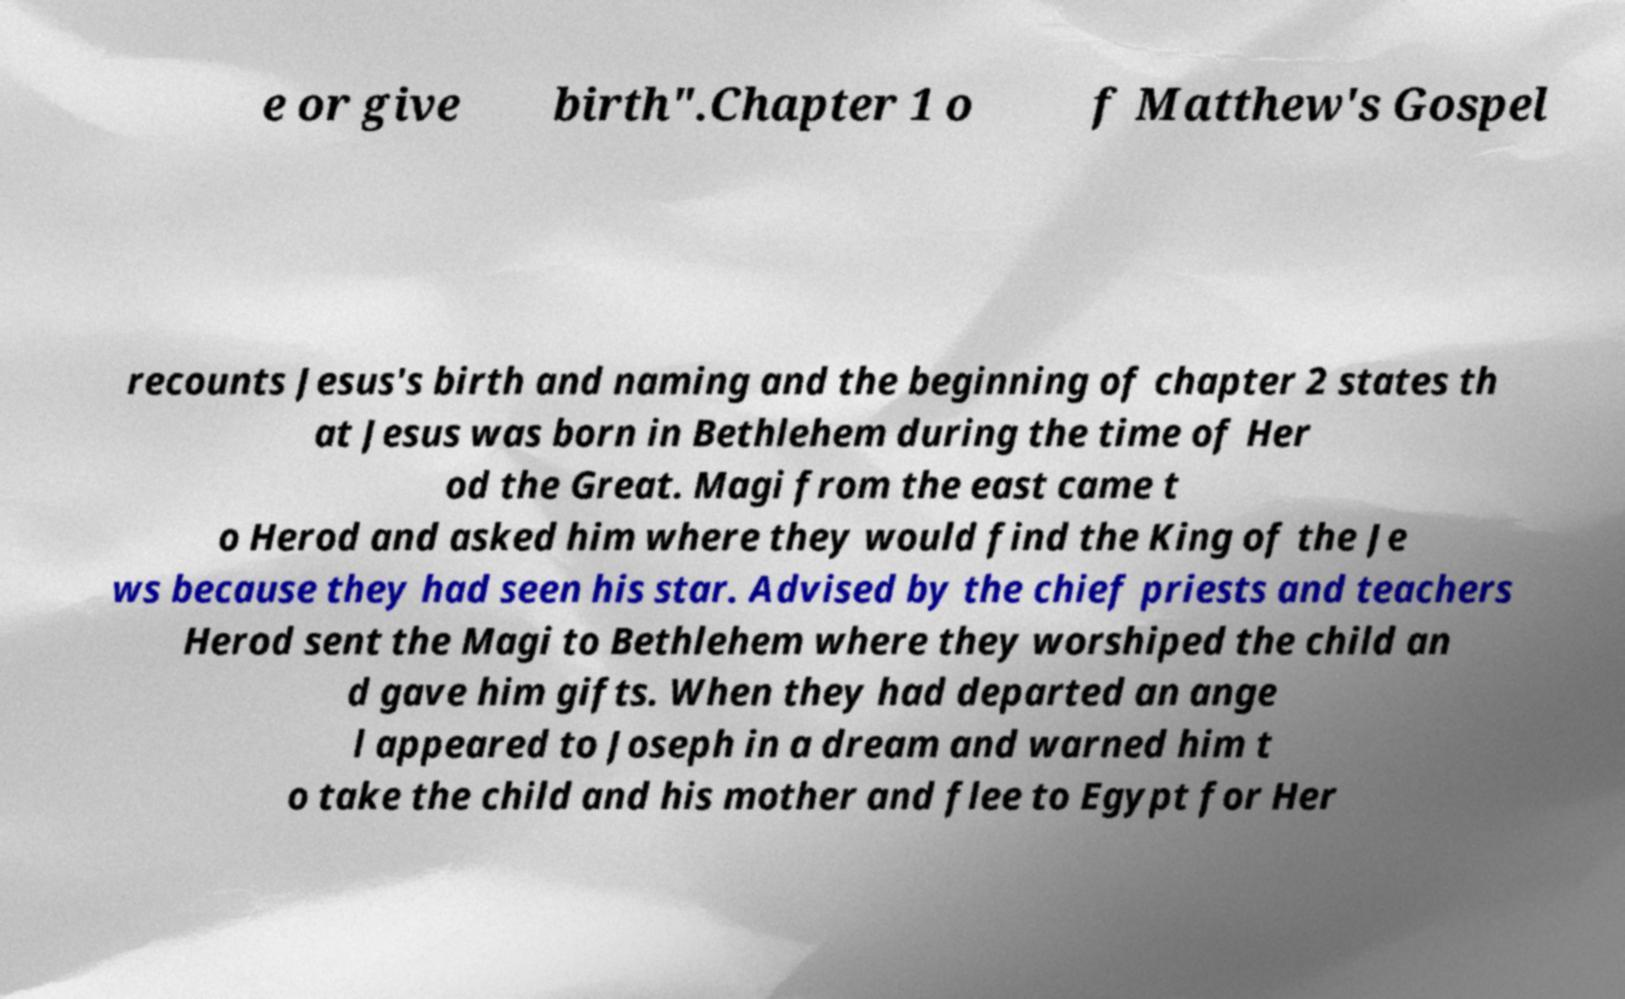I need the written content from this picture converted into text. Can you do that? e or give birth".Chapter 1 o f Matthew's Gospel recounts Jesus's birth and naming and the beginning of chapter 2 states th at Jesus was born in Bethlehem during the time of Her od the Great. Magi from the east came t o Herod and asked him where they would find the King of the Je ws because they had seen his star. Advised by the chief priests and teachers Herod sent the Magi to Bethlehem where they worshiped the child an d gave him gifts. When they had departed an ange l appeared to Joseph in a dream and warned him t o take the child and his mother and flee to Egypt for Her 